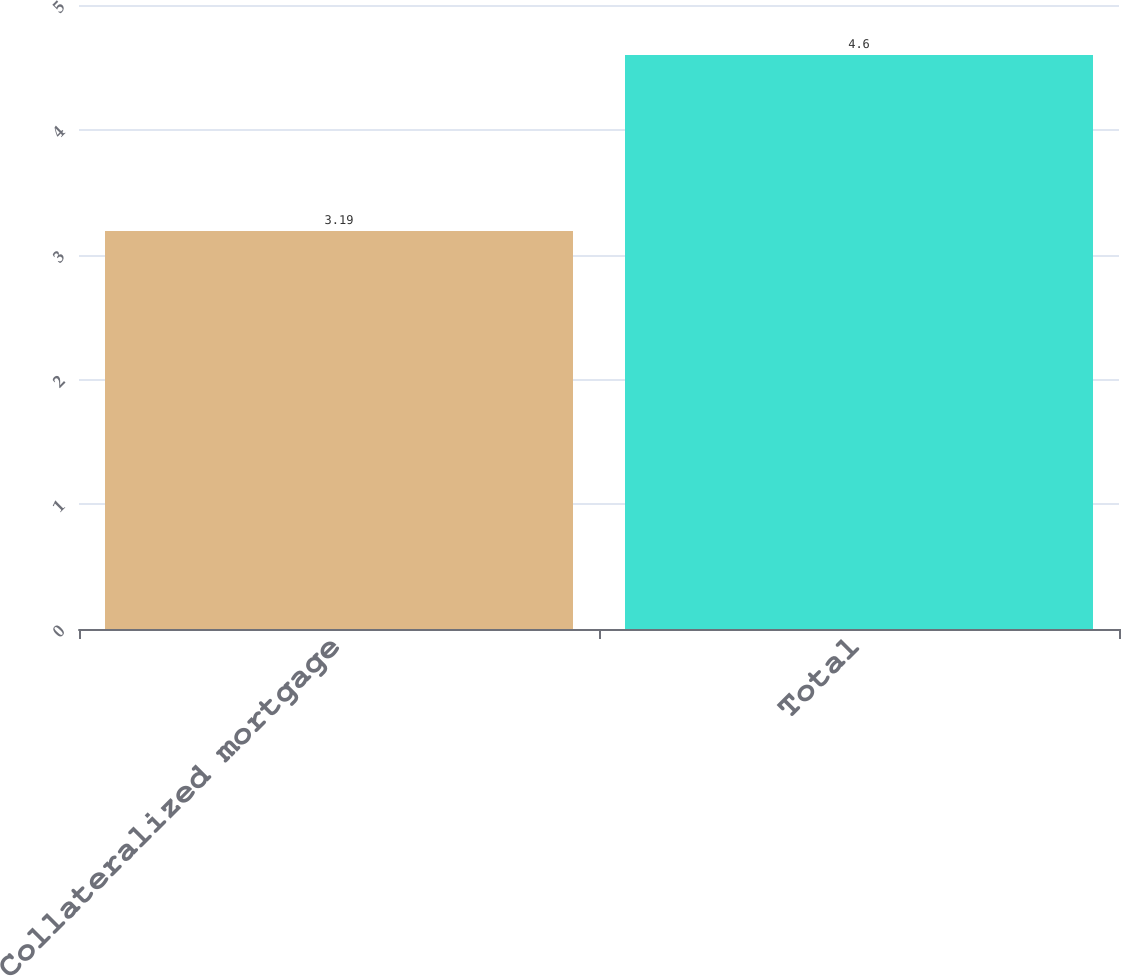<chart> <loc_0><loc_0><loc_500><loc_500><bar_chart><fcel>Collateralized mortgage<fcel>Total<nl><fcel>3.19<fcel>4.6<nl></chart> 